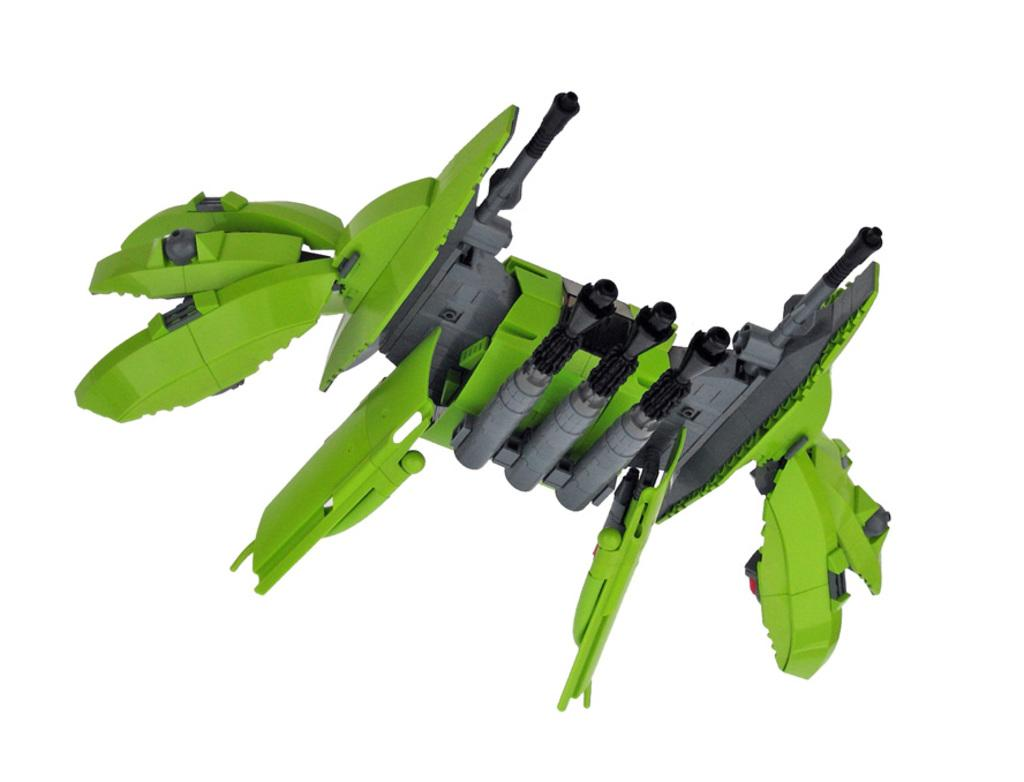What is the main subject in the center of the image? There is a drawing of a machine in the center of the image. Where is the nearest park to the machine in the image? There is no information about a park or its location in relation to the machine in the image. 